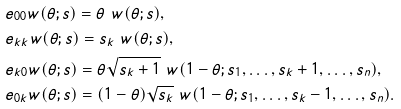Convert formula to latex. <formula><loc_0><loc_0><loc_500><loc_500>& e _ { 0 0 } w ( \theta ; s ) = \theta \ w ( \theta ; s ) , \\ & e _ { k k } w ( \theta ; s ) = s _ { k } \ w ( \theta ; s ) , \\ & e _ { k 0 } w ( \theta ; s ) = \theta \sqrt { s _ { k } + 1 } \ w ( 1 - \theta ; s _ { 1 } , \dots , s _ { k } + 1 , \dots , s _ { n } ) , \\ & e _ { 0 k } w ( \theta ; s ) = ( 1 - \theta ) \sqrt { s _ { k } } \ w ( 1 - \theta ; s _ { 1 } , \dots , s _ { k } - 1 , \dots , s _ { n } ) .</formula> 